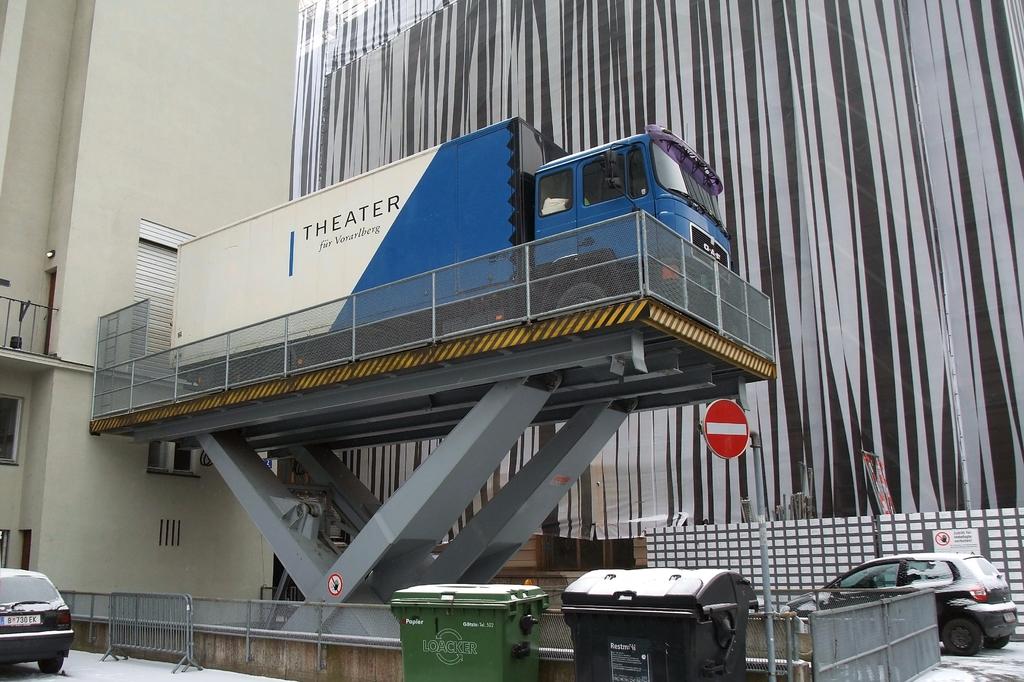What company is on the side of this truck?
Make the answer very short. Theater. 